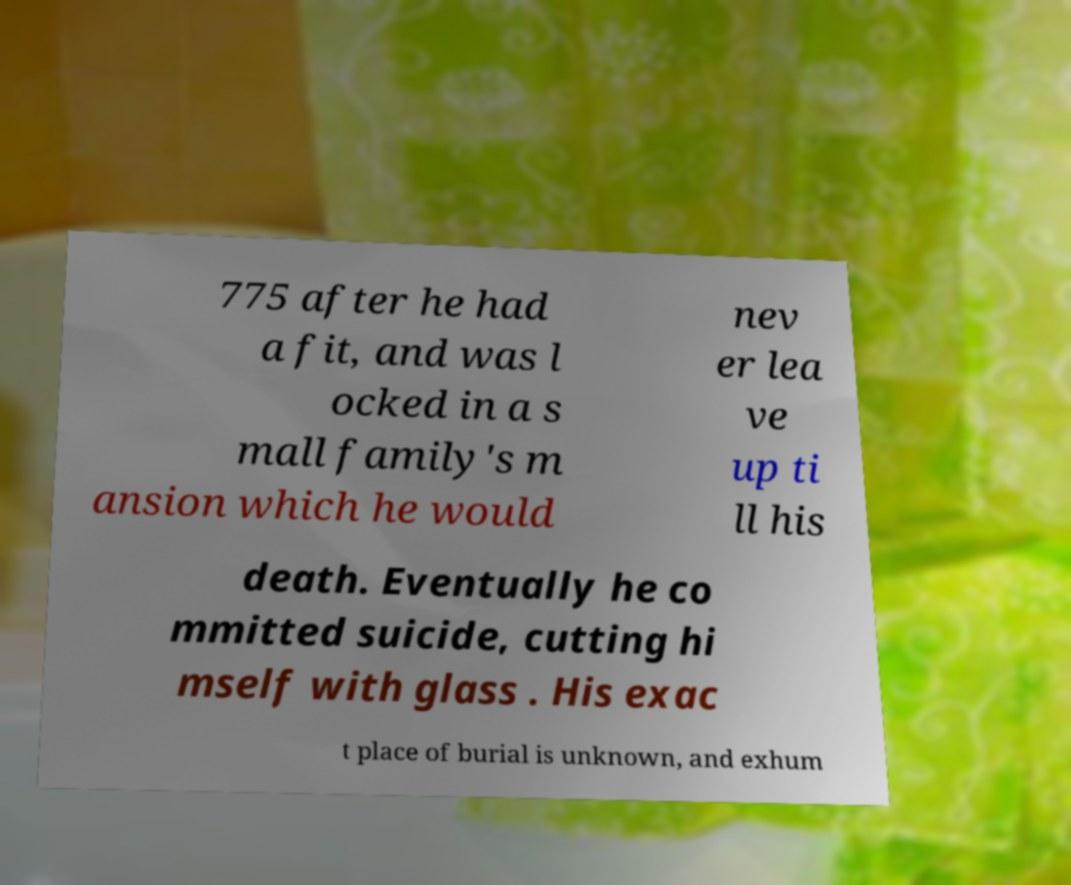Could you assist in decoding the text presented in this image and type it out clearly? 775 after he had a fit, and was l ocked in a s mall family's m ansion which he would nev er lea ve up ti ll his death. Eventually he co mmitted suicide, cutting hi mself with glass . His exac t place of burial is unknown, and exhum 